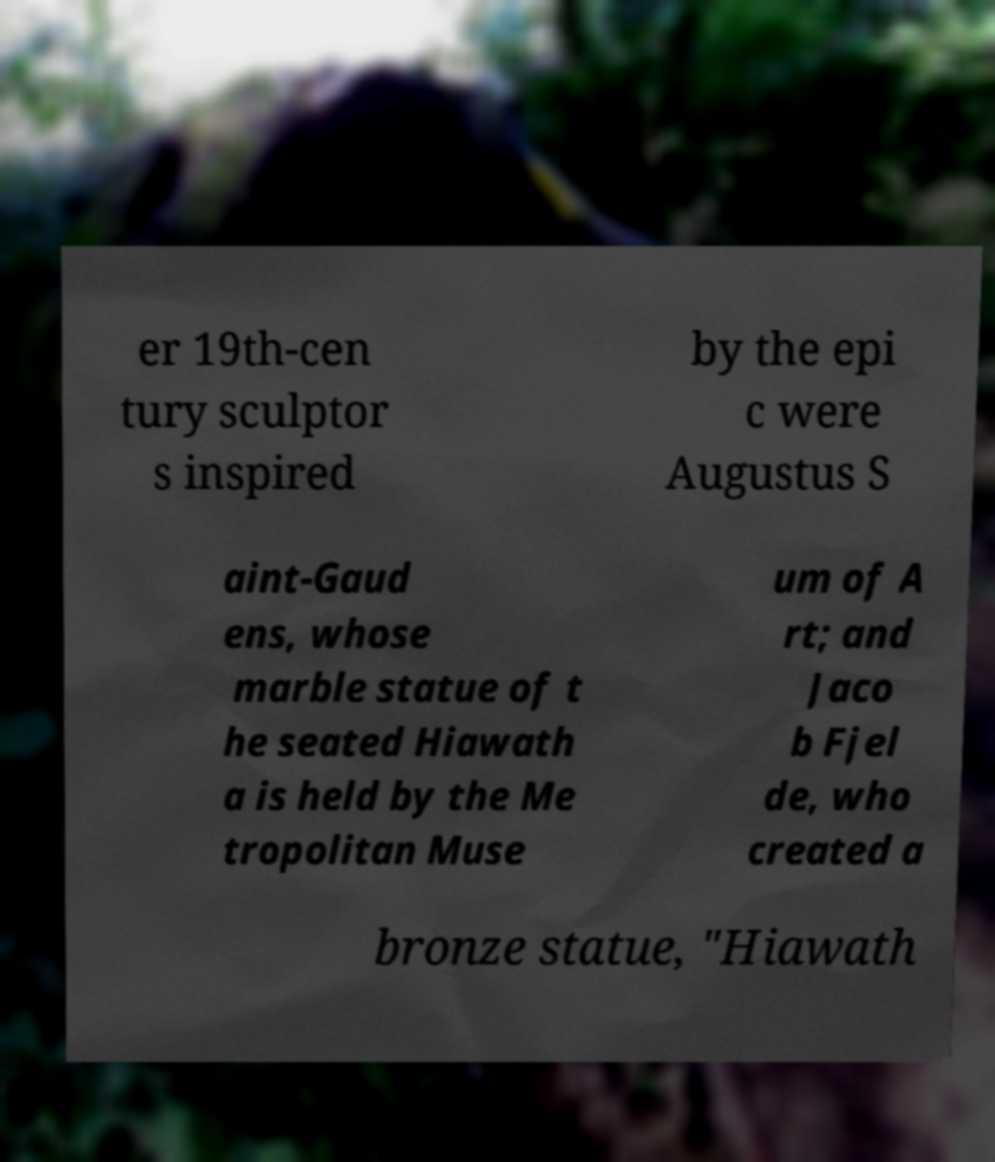What messages or text are displayed in this image? I need them in a readable, typed format. er 19th-cen tury sculptor s inspired by the epi c were Augustus S aint-Gaud ens, whose marble statue of t he seated Hiawath a is held by the Me tropolitan Muse um of A rt; and Jaco b Fjel de, who created a bronze statue, "Hiawath 